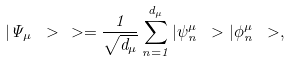Convert formula to latex. <formula><loc_0><loc_0><loc_500><loc_500>| \Psi _ { \mu } \ > \, \ > = \frac { 1 } { \sqrt { d _ { \mu } } } \sum _ { n = 1 } ^ { d _ { \mu } } | \psi _ { n } ^ { \mu } \ > | \phi _ { n } ^ { \mu } \ > ,</formula> 